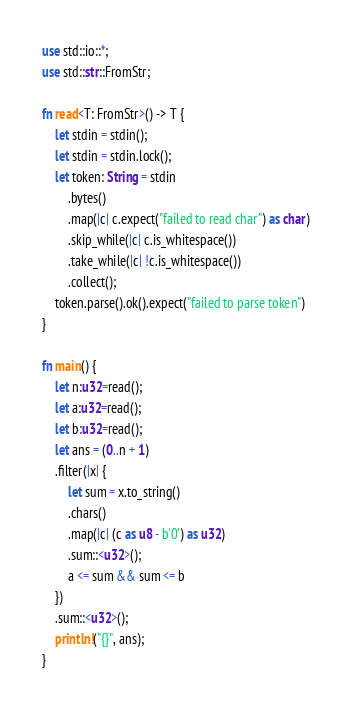Convert code to text. <code><loc_0><loc_0><loc_500><loc_500><_Rust_>use std::io::*;
use std::str::FromStr;

fn read<T: FromStr>() -> T {
    let stdin = stdin();
    let stdin = stdin.lock();
    let token: String = stdin
        .bytes()
        .map(|c| c.expect("failed to read char") as char)
        .skip_while(|c| c.is_whitespace())
        .take_while(|c| !c.is_whitespace())
        .collect();
    token.parse().ok().expect("failed to parse token")
}

fn main() {
    let n:u32=read();
    let a:u32=read();
    let b:u32=read();
    let ans = (0..n + 1)
    .filter(|x| {
        let sum = x.to_string()
        .chars()
        .map(|c| (c as u8 - b'0') as u32)
        .sum::<u32>();
        a <= sum && sum <= b
    })
    .sum::<u32>();
    println!("{}", ans);
}</code> 